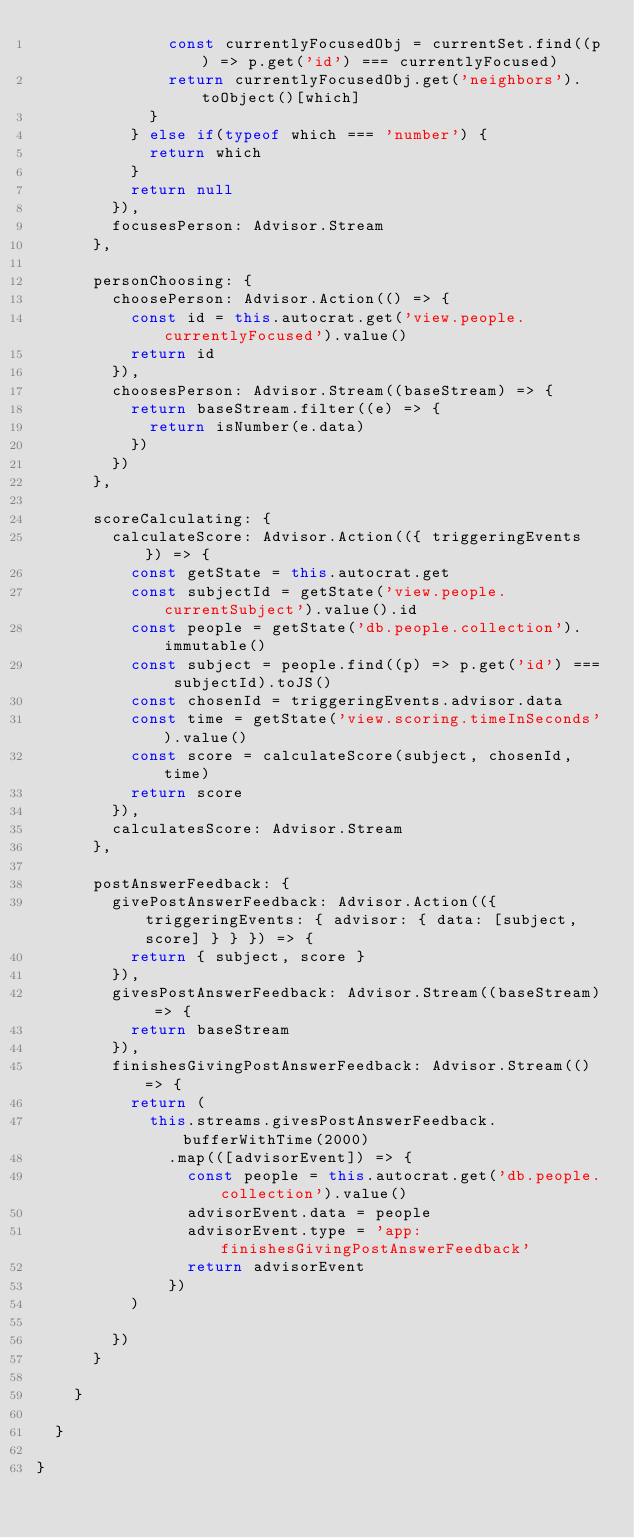<code> <loc_0><loc_0><loc_500><loc_500><_JavaScript_>              const currentlyFocusedObj = currentSet.find((p) => p.get('id') === currentlyFocused)
              return currentlyFocusedObj.get('neighbors').toObject()[which]
            }
          } else if(typeof which === 'number') {
            return which
          }
          return null
        }),
        focusesPerson: Advisor.Stream
      },

      personChoosing: {
        choosePerson: Advisor.Action(() => {
          const id = this.autocrat.get('view.people.currentlyFocused').value()
          return id
        }),
        choosesPerson: Advisor.Stream((baseStream) => {
          return baseStream.filter((e) => {
            return isNumber(e.data)
          })
        })
      },

      scoreCalculating: {
        calculateScore: Advisor.Action(({ triggeringEvents }) => {
          const getState = this.autocrat.get
          const subjectId = getState('view.people.currentSubject').value().id
          const people = getState('db.people.collection').immutable()
          const subject = people.find((p) => p.get('id') === subjectId).toJS()
          const chosenId = triggeringEvents.advisor.data
          const time = getState('view.scoring.timeInSeconds').value()
          const score = calculateScore(subject, chosenId, time)
          return score
        }),
        calculatesScore: Advisor.Stream
      },

      postAnswerFeedback: {
        givePostAnswerFeedback: Advisor.Action(({ triggeringEvents: { advisor: { data: [subject, score] } } }) => {
          return { subject, score }
        }),
        givesPostAnswerFeedback: Advisor.Stream((baseStream) => {
          return baseStream
        }),
        finishesGivingPostAnswerFeedback: Advisor.Stream(() => {
          return (
            this.streams.givesPostAnswerFeedback.bufferWithTime(2000)
              .map(([advisorEvent]) => {
                const people = this.autocrat.get('db.people.collection').value()
                advisorEvent.data = people
                advisorEvent.type = 'app:finishesGivingPostAnswerFeedback'
                return advisorEvent
              })
          )

        })
      }

    }

  }

}
</code> 